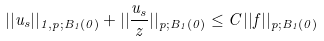Convert formula to latex. <formula><loc_0><loc_0><loc_500><loc_500>| | u _ { s } | | _ { 1 , p ; B _ { 1 } ( 0 ) } + | | \frac { u _ { s } } { z } | | _ { p ; B _ { 1 } ( 0 ) } \leq C | | f | | _ { p ; B _ { 1 } ( 0 ) }</formula> 